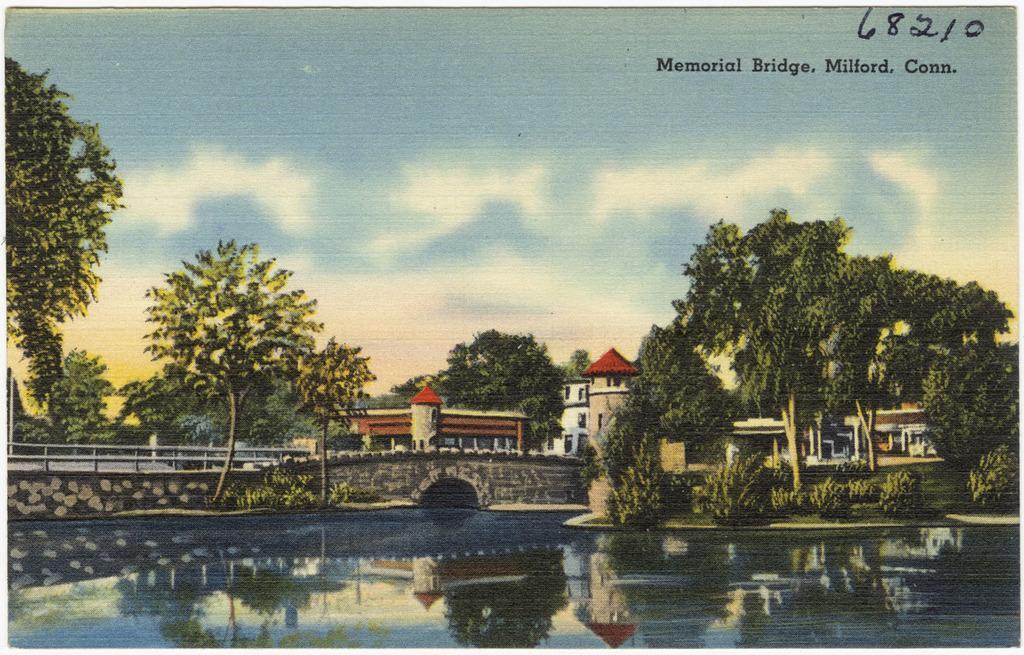Can you describe this image briefly? In this image I can see water, bridge, trees, buildings, clouds, sky and I can see this complete picture is a painting. I can also see something is written over here. 